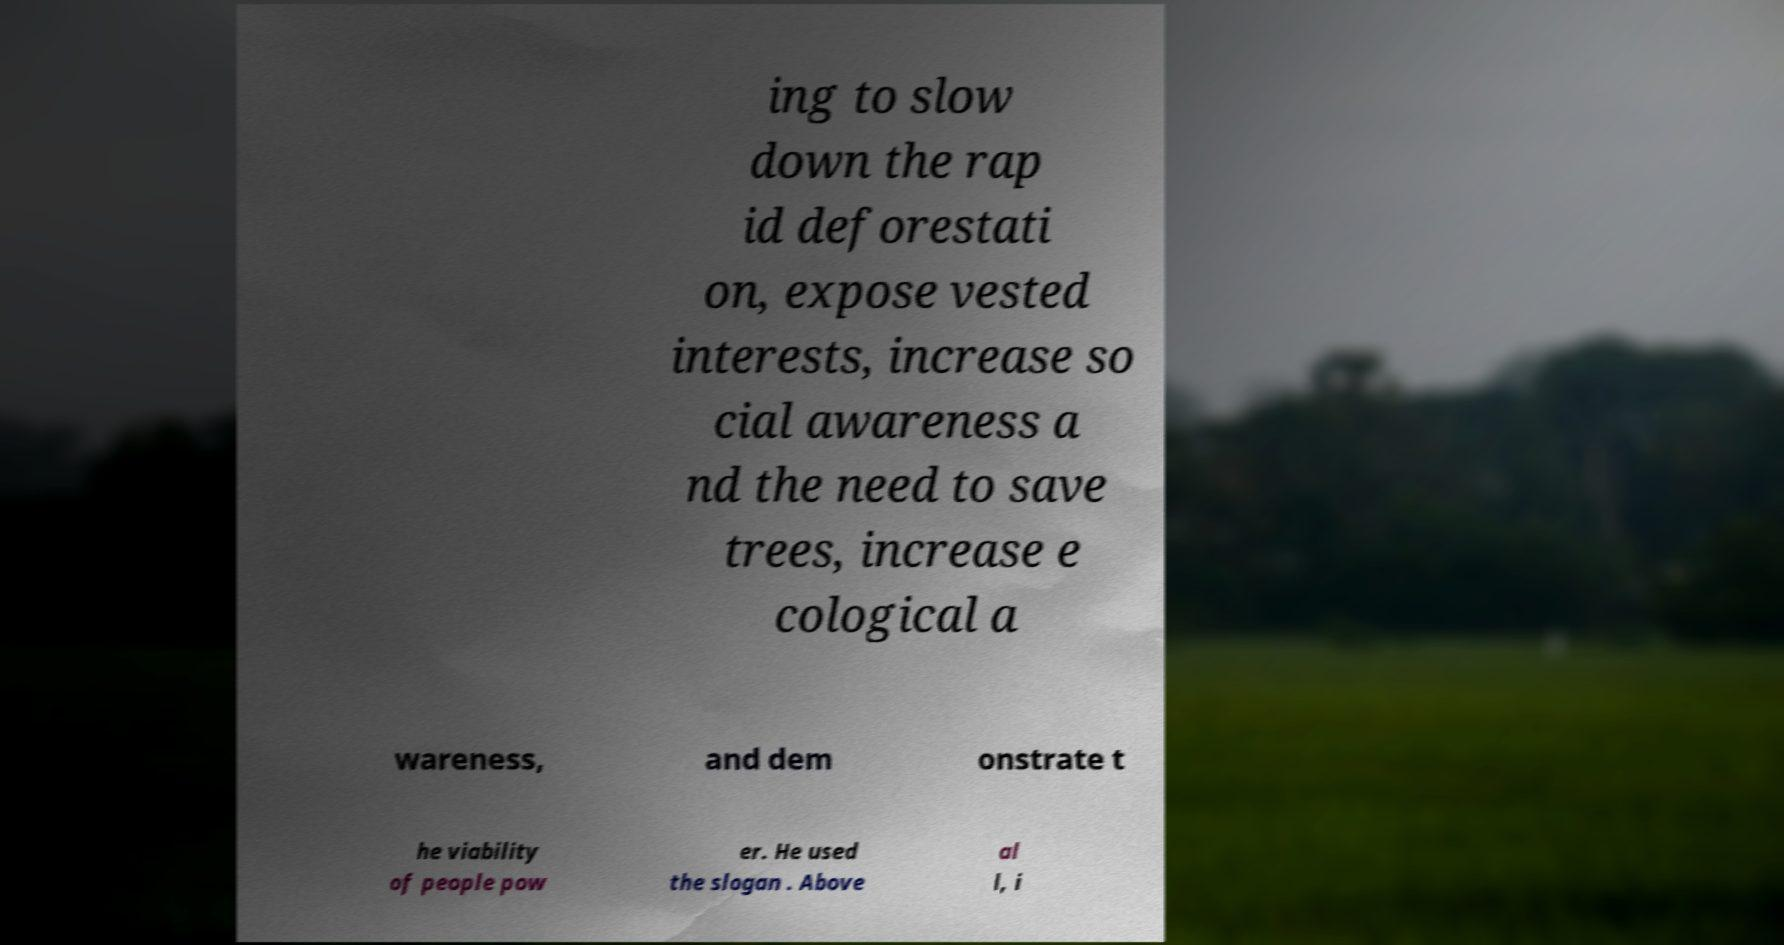I need the written content from this picture converted into text. Can you do that? ing to slow down the rap id deforestati on, expose vested interests, increase so cial awareness a nd the need to save trees, increase e cological a wareness, and dem onstrate t he viability of people pow er. He used the slogan . Above al l, i 